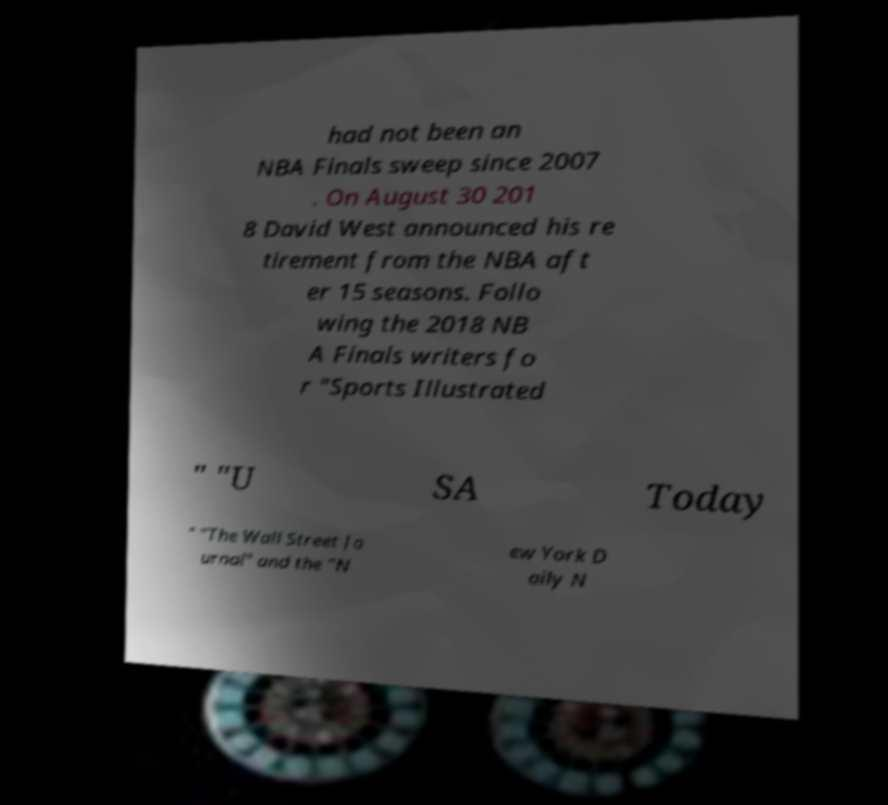Please read and relay the text visible in this image. What does it say? had not been an NBA Finals sweep since 2007 . On August 30 201 8 David West announced his re tirement from the NBA aft er 15 seasons. Follo wing the 2018 NB A Finals writers fo r "Sports Illustrated " "U SA Today " "The Wall Street Jo urnal" and the "N ew York D aily N 